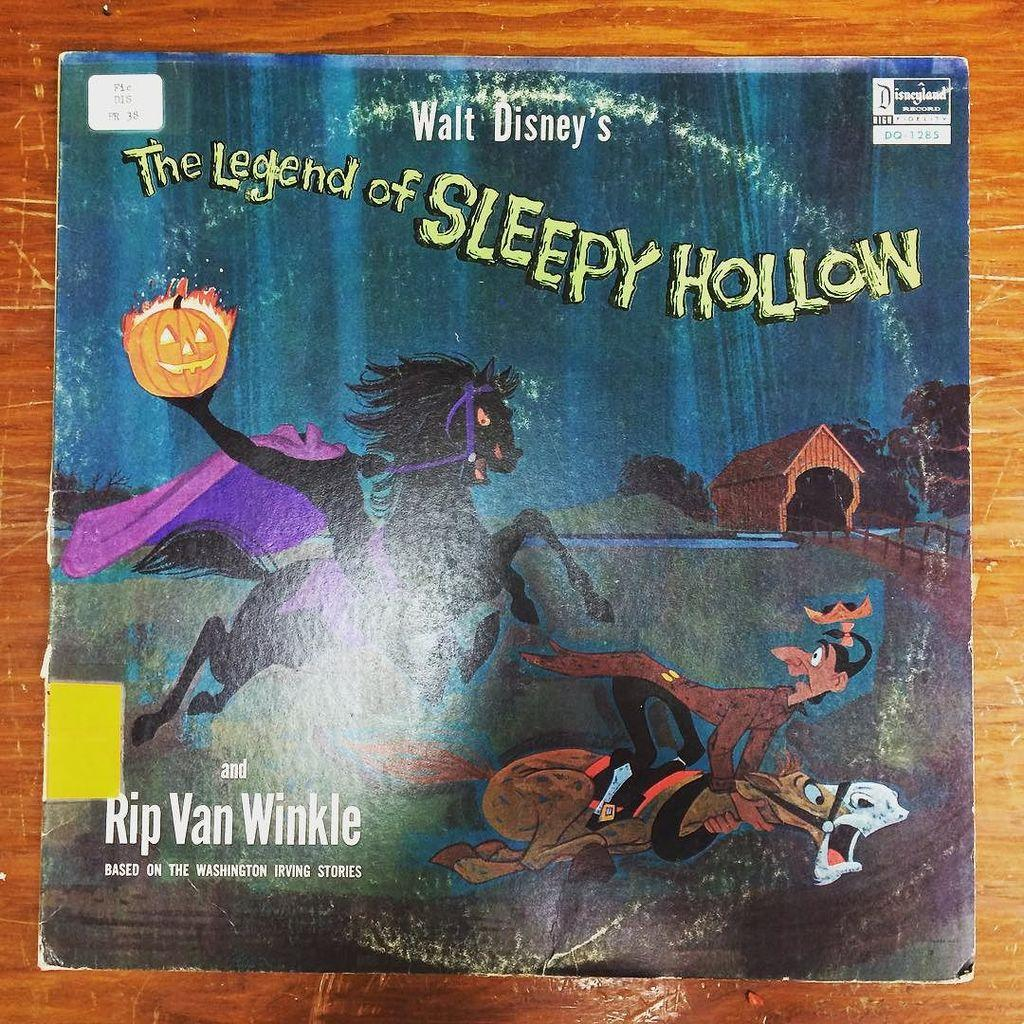<image>
Create a compact narrative representing the image presented. A book titled Sleepy Hollow has a black horse on the front. 